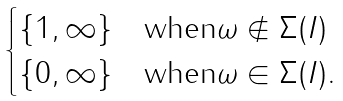<formula> <loc_0><loc_0><loc_500><loc_500>\begin{cases} \{ 1 , \infty \} & \text {when} \omega \notin \Sigma ( I ) \\ \{ 0 , \infty \} & \text {when} \omega \in \Sigma ( I ) . \end{cases}</formula> 